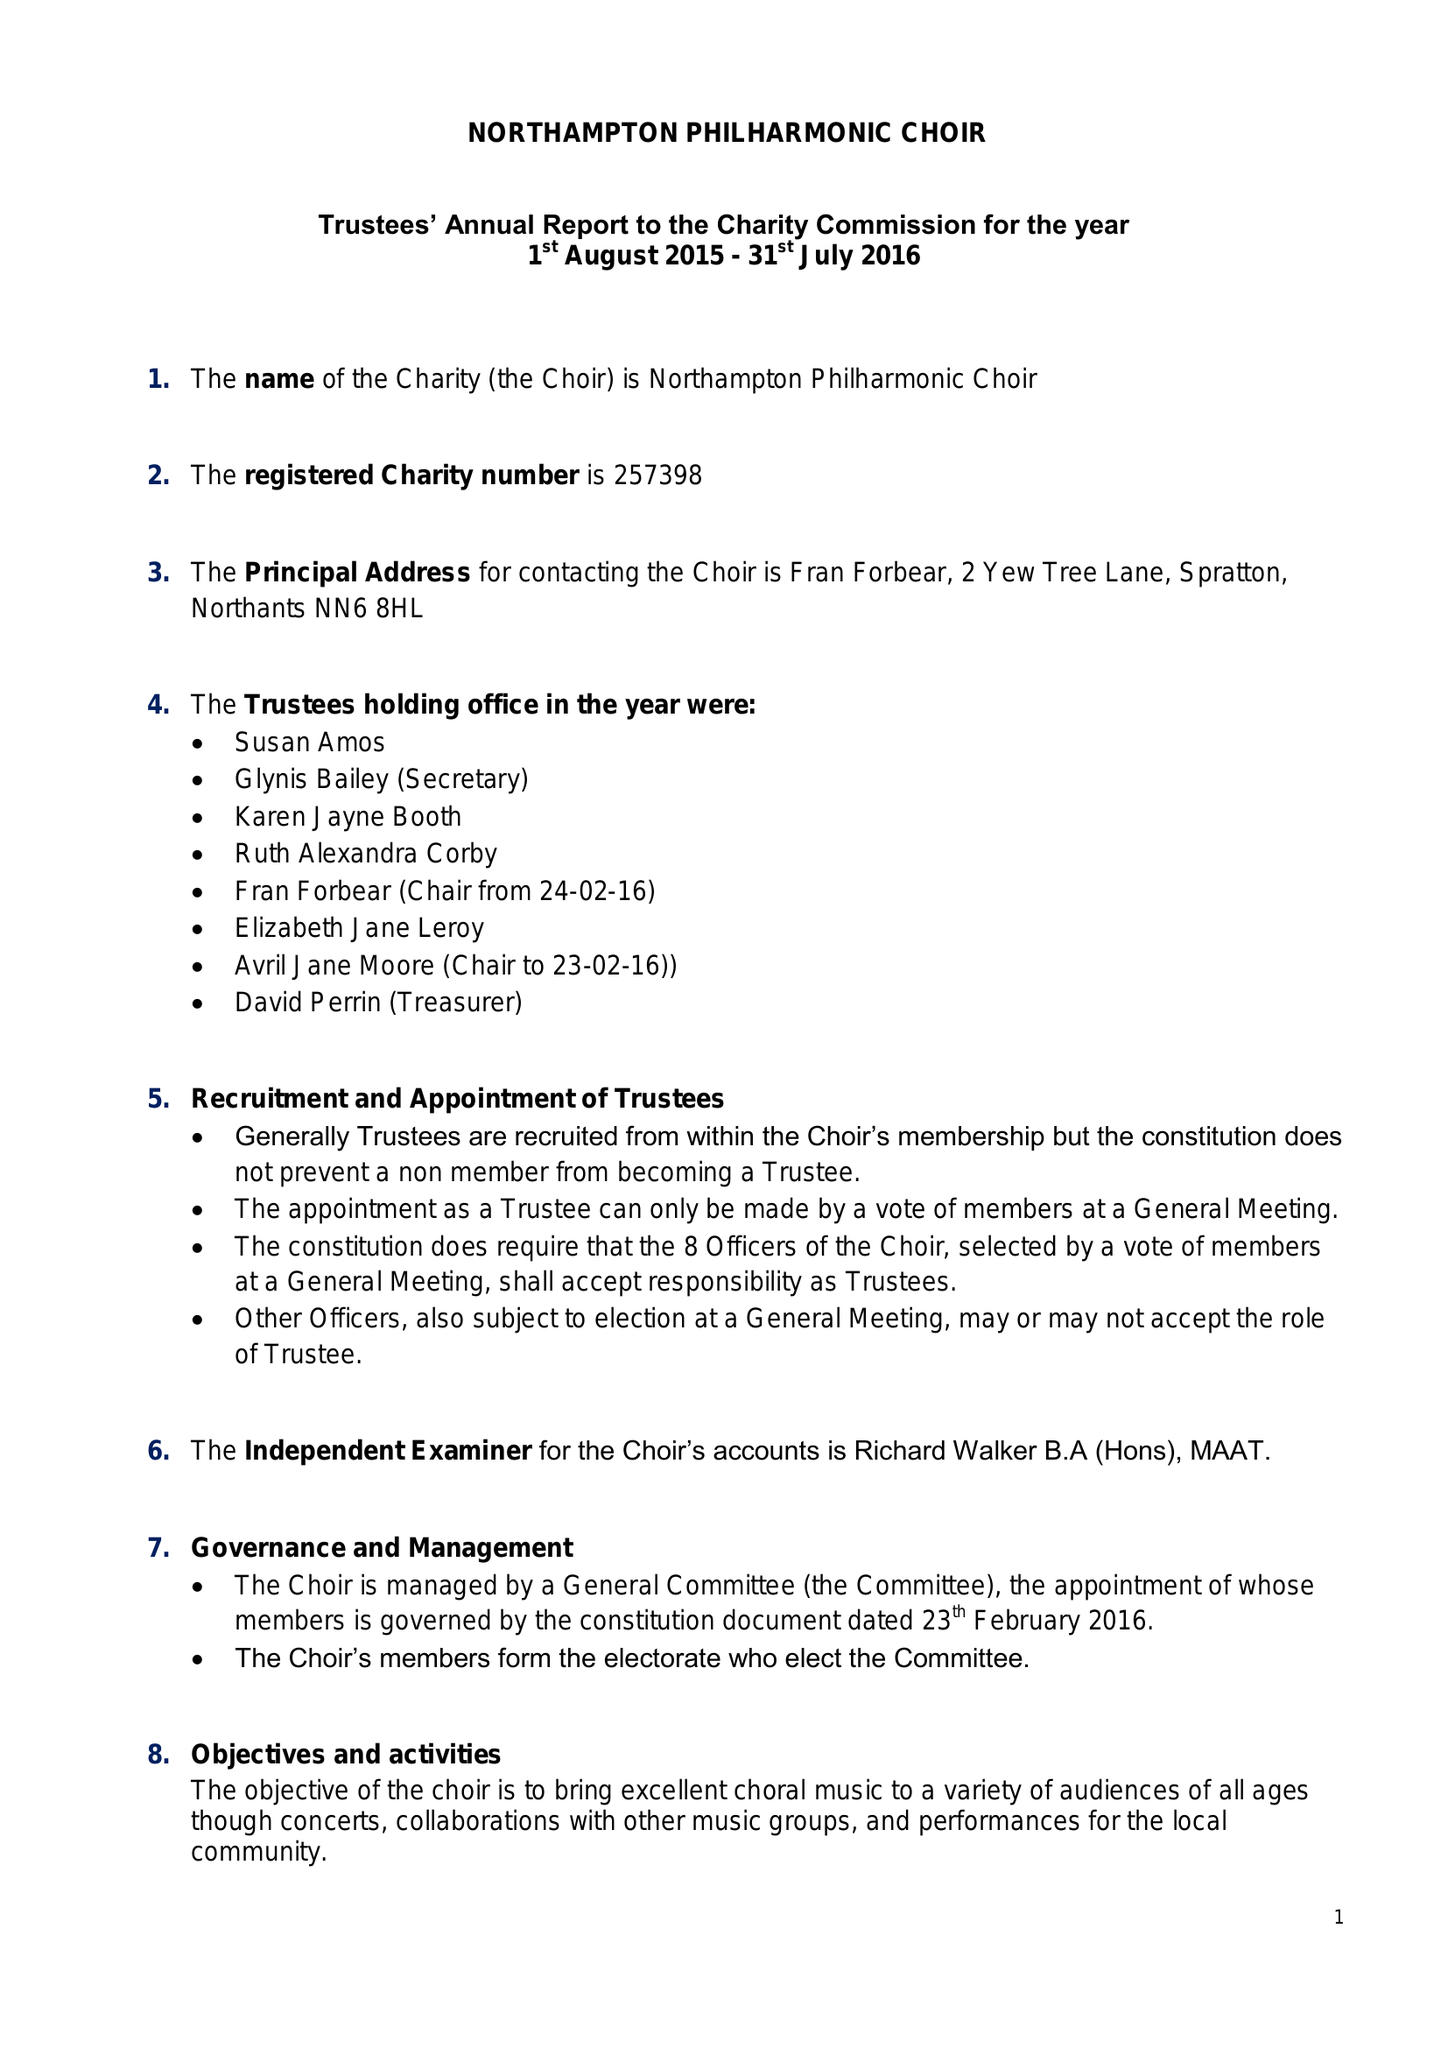What is the value for the address__street_line?
Answer the question using a single word or phrase. 2 YEW TREE LANE 